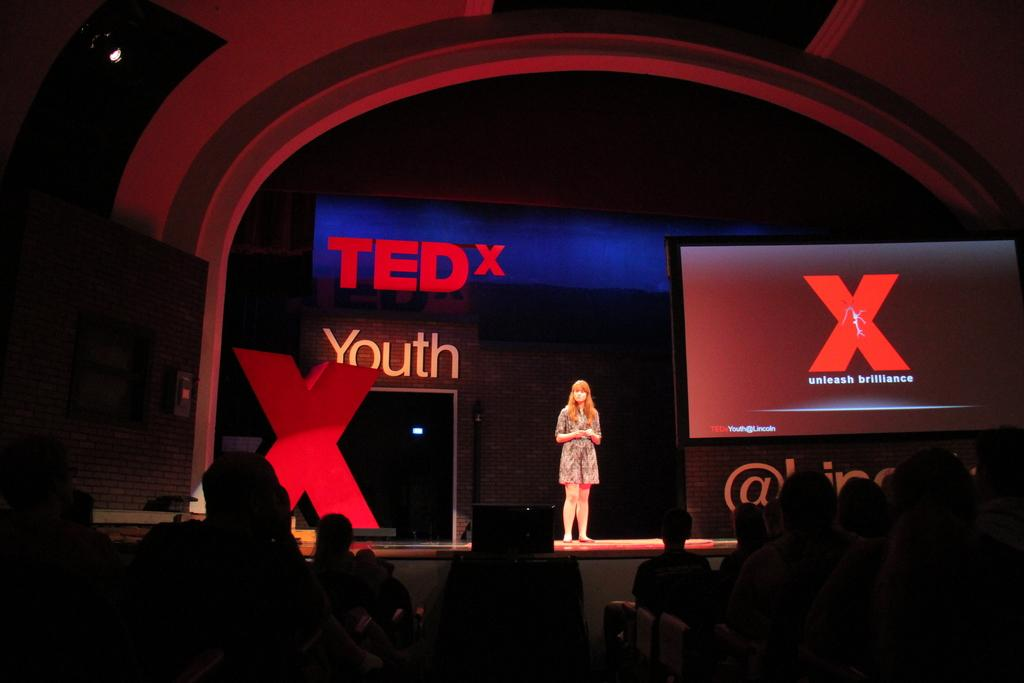What is the primary subject of the image? There is a woman standing in the image. Where is the woman standing? The woman is standing on the floor. What can be seen in the background of the image? There is a screen, a hoarding, and a wall visible in the background. Are there any other people visible in the image? Yes, there are people visible at the bottom of the image. What type of writing can be seen on the sail in the image? There is no sail present in the image, so it is not possible to determine what, if any, writing might be seen on it. 